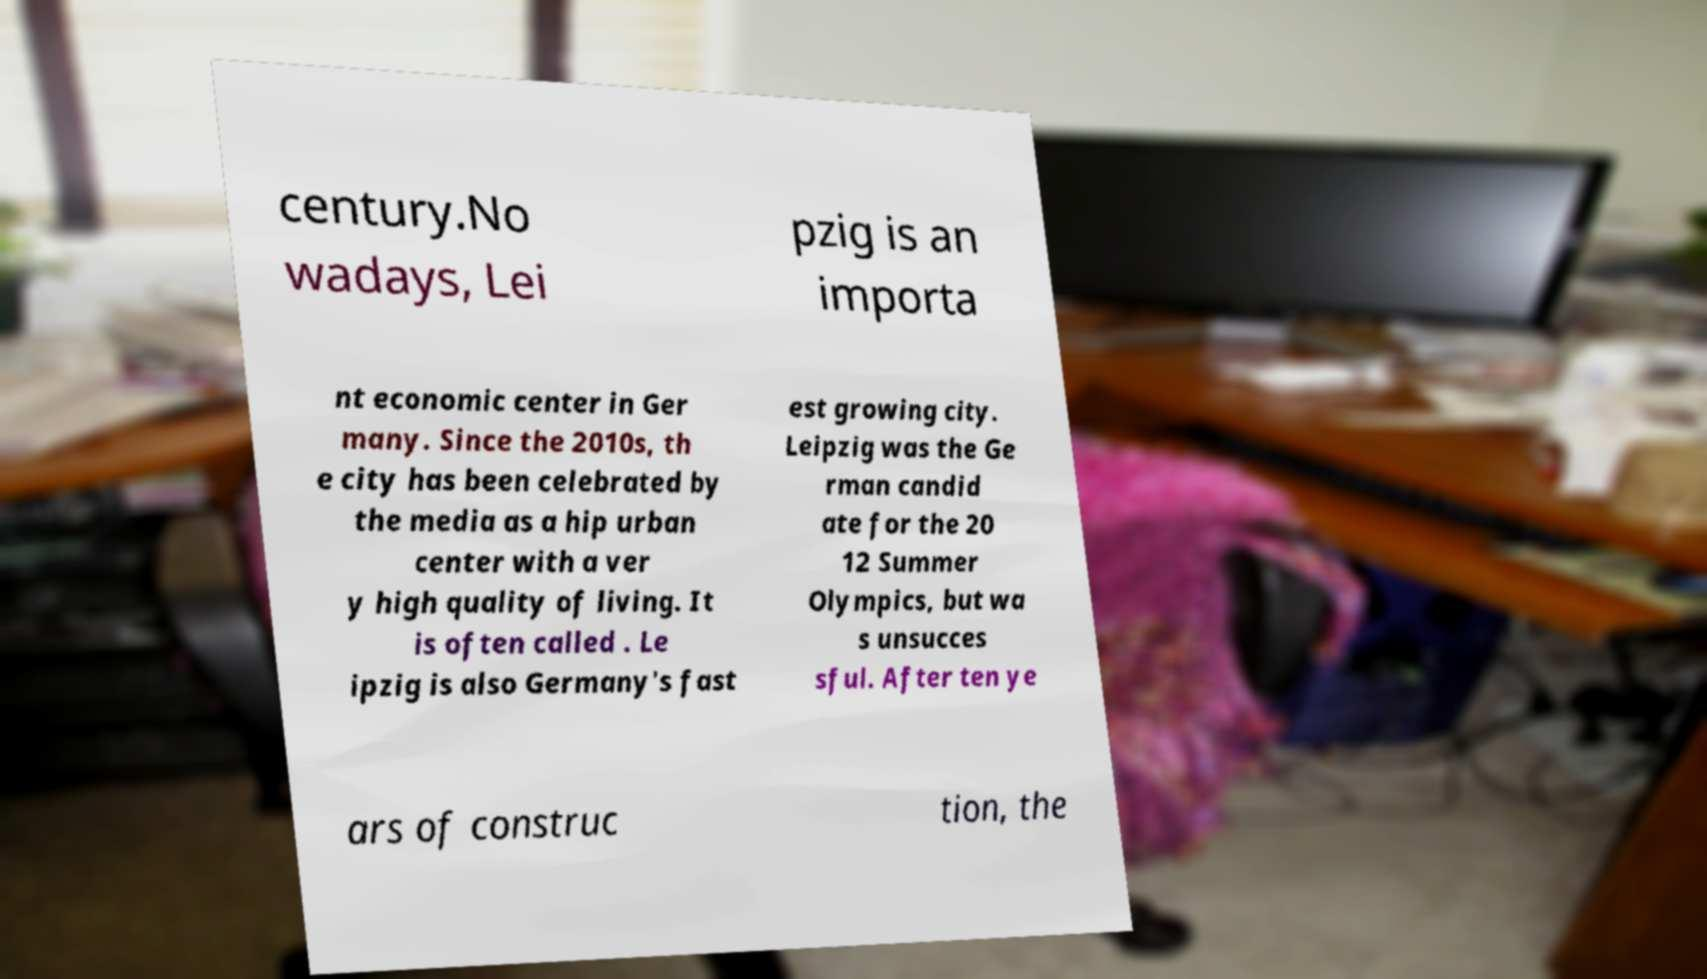Could you extract and type out the text from this image? century.No wadays, Lei pzig is an importa nt economic center in Ger many. Since the 2010s, th e city has been celebrated by the media as a hip urban center with a ver y high quality of living. It is often called . Le ipzig is also Germany's fast est growing city. Leipzig was the Ge rman candid ate for the 20 12 Summer Olympics, but wa s unsucces sful. After ten ye ars of construc tion, the 